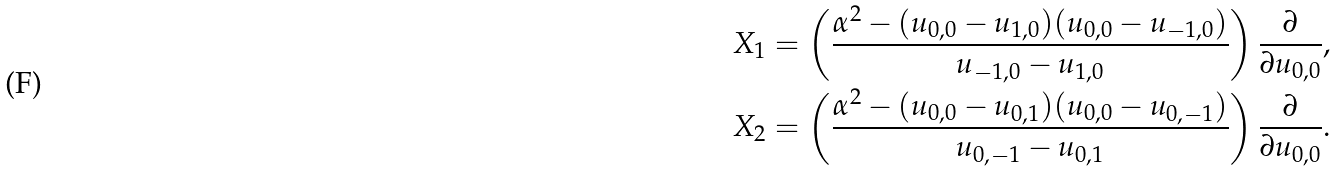<formula> <loc_0><loc_0><loc_500><loc_500>X _ { 1 } & = \left ( \frac { \alpha ^ { 2 } - ( u _ { 0 , 0 } - u _ { 1 , 0 } ) ( u _ { 0 , 0 } - u _ { - 1 , 0 } ) } { u _ { - 1 , 0 } - u _ { 1 , 0 } } \right ) \frac { \partial } { \partial u _ { 0 , 0 } } , \\ X _ { 2 } & = \left ( \frac { \alpha ^ { 2 } - ( u _ { 0 , 0 } - u _ { 0 , 1 } ) ( u _ { 0 , 0 } - u _ { 0 , - 1 } ) } { u _ { 0 , - 1 } - u _ { 0 , 1 } } \right ) \frac { \partial } { \partial u _ { 0 , 0 } } .</formula> 